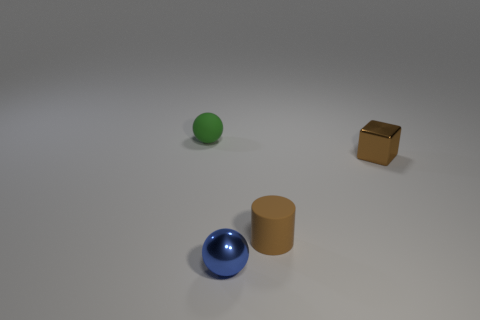What is the size of the green thing that is the same shape as the tiny blue thing?
Ensure brevity in your answer.  Small. Is the metallic block the same color as the small rubber cylinder?
Make the answer very short. Yes. What color is the small thing that is both in front of the brown cube and behind the blue shiny sphere?
Keep it short and to the point. Brown. Does the metallic thing behind the brown cylinder have the same size as the green thing?
Your answer should be compact. Yes. Is there anything else that is the same shape as the brown matte object?
Make the answer very short. No. Does the tiny blue ball have the same material as the small thing that is on the left side of the small metallic sphere?
Offer a terse response. No. What number of gray objects are either small metallic objects or matte balls?
Ensure brevity in your answer.  0. Are there any green things?
Offer a terse response. Yes. There is a tiny ball that is in front of the brown object that is to the left of the brown metallic block; are there any brown things that are behind it?
Provide a succinct answer. Yes. Are there any other things that are the same size as the brown metallic thing?
Ensure brevity in your answer.  Yes. 